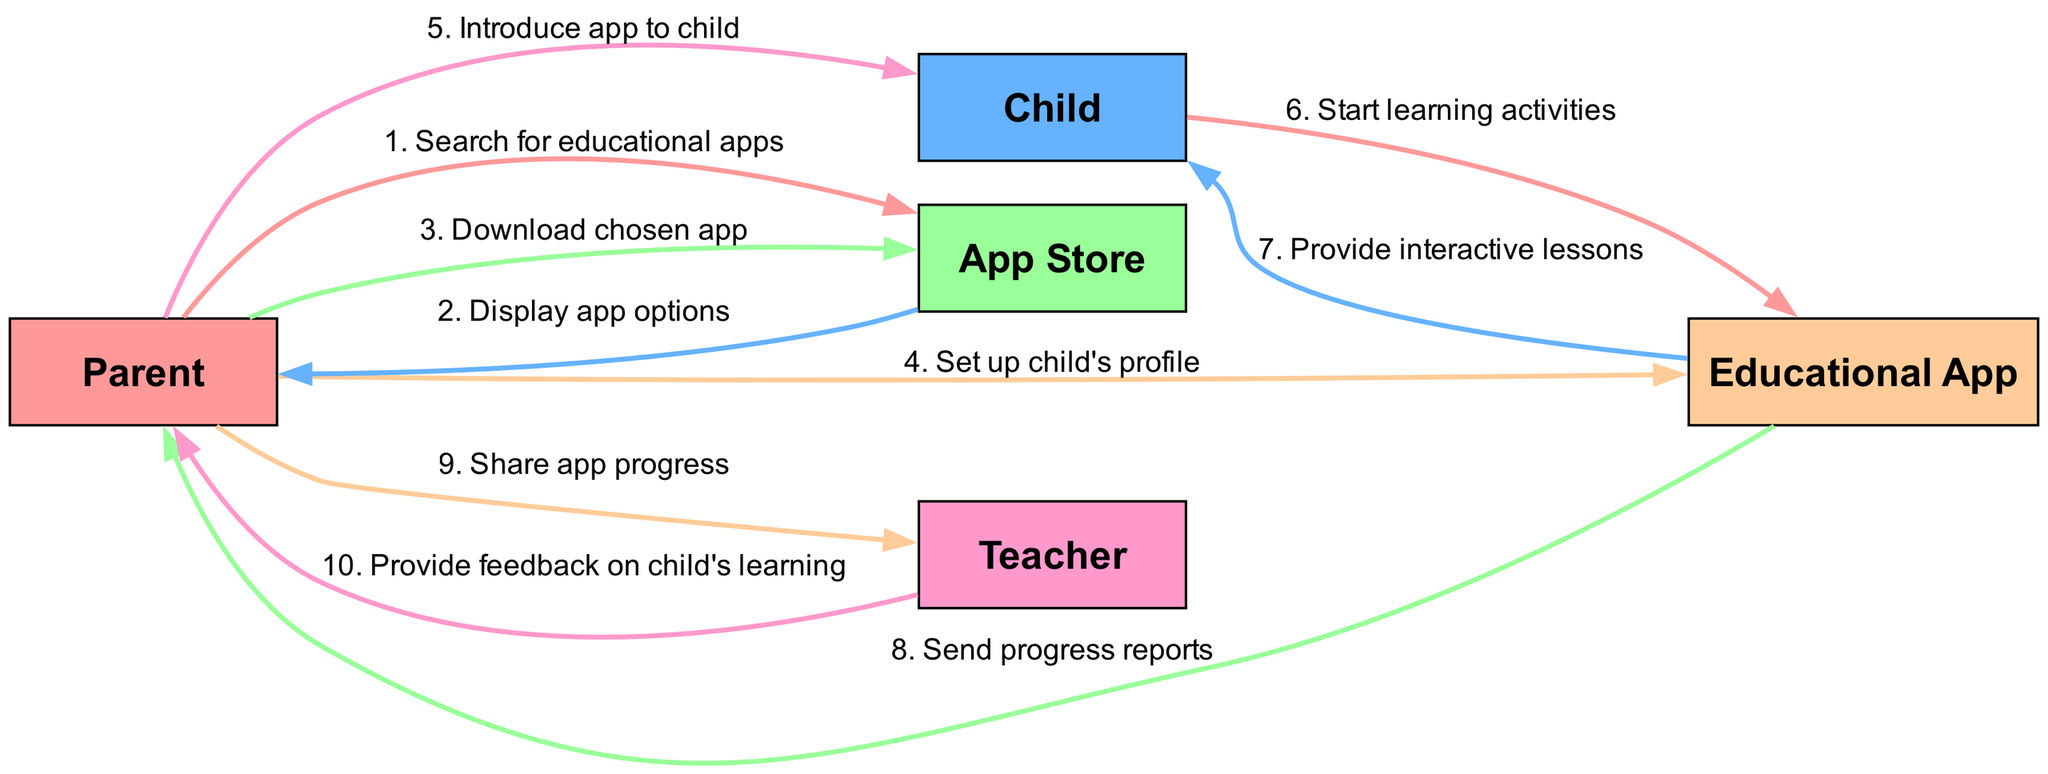What is the first action taken by the Parent? The Parent's first action is to search for educational apps in the App Store. This is represented as the first message in the sequence of interactions.
Answer: Search for educational apps How many actors are involved in the sequence? The diagram lists five distinct actors: Parent, Child, App Store, Educational App, and Teacher, making it a total of five actors.
Answer: Five What message follows after the Parent introduces the app to the Child? The next message following the Parent introducing the app to the Child is when the Child starts learning activities within the Educational App, making it the subsequent interaction in the diagram.
Answer: Start learning activities Which actor receives progress reports from the Educational App? The Parent receives progress reports from the Educational App as indicated in the sequence, representing the communication flow towards the Parent regarding the Child's learning progress.
Answer: Parent What action does the Teacher take after receiving information from the Parent? After the Parent shares the app progress, the Teacher provides feedback on the Child's learning, representing an evaluative response to the progress shared by the Parent.
Answer: Provide feedback on child's learning What is the total number of messages exchanged in the sequence? There are ten messages exchanged in total, as evidenced by the count of interactions represented in the diagram's sequence, each enumerated from one to ten.
Answer: Ten What is the role of the App Store in the lifecycle of the educational app? The App Store's role is to display app options after the Parent searches for educational apps, facilitating the process of finding and selecting suitable applications for download.
Answer: Display app options What type of content does the Educational App provide to the Child? The Educational App provides interactive lessons to the Child, enhancing the learning experience by engaging the user through interactive content as indicated in the sequence.
Answer: Provide interactive lessons 